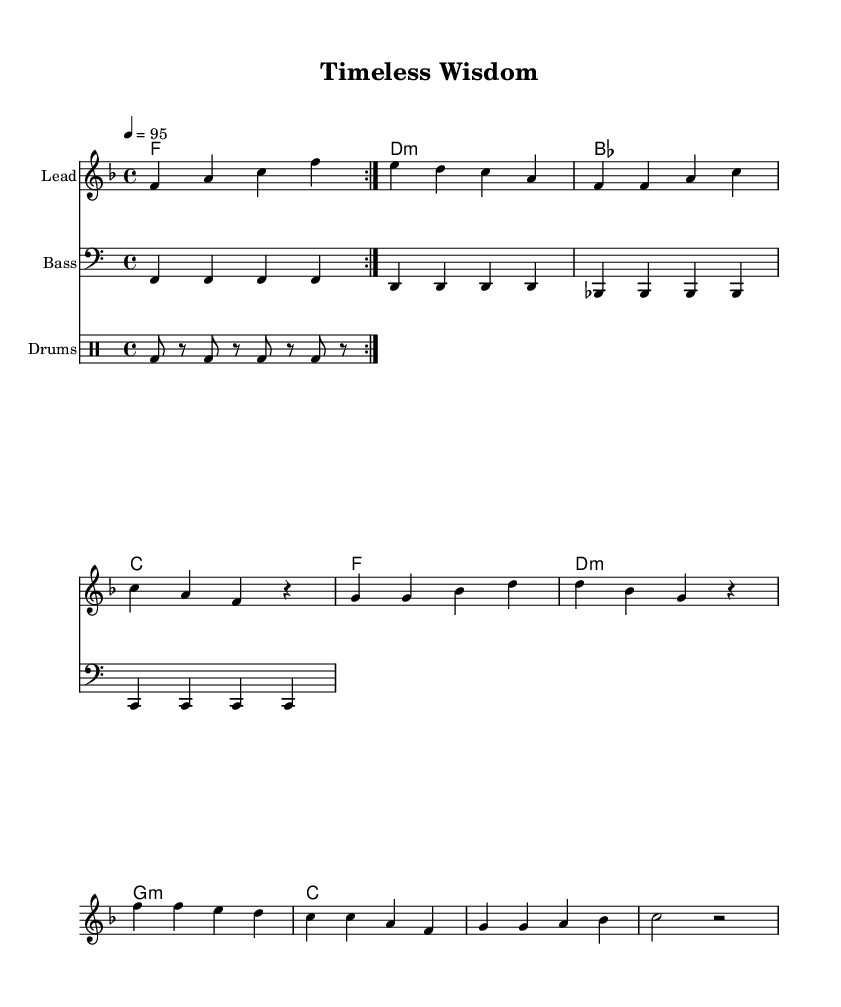What is the key signature of this music? The key signature is F major, which has one flat (B♭). The key can be identified by the key indication at the beginning of the score.
Answer: F major What is the time signature of this piece? The time signature is 4/4, which indicates that there are four beats in each measure and the quarter note gets one beat. This is marked at the beginning of the score as well.
Answer: 4/4 What is the tempo marking provided in the score? The tempo marking is "4 = 95", meaning that there should be 95 beats per minute, described in quarter notes. This is indicated at the beginning of the score.
Answer: 95 How many measures are in the verse section? The verse section contains four measures, each with notes indicated in the melody part. Counting the measures visually will confirm this.
Answer: 4 What is the rhythmic pattern used in the drum part? The drum pattern consists of a repeating kick drum on the eighth notes, where each kick occurs on the first and the second eighth note of the beats. This is crafted by observing the drum notation provided.
Answer: Kick drum Who is the musical piece celebrating through its lyrics? The piece celebrates elders and the wisdom they pass on to younger generations, as suggested by the thematic content of the lyrics presented below the melody.
Answer: Elders 